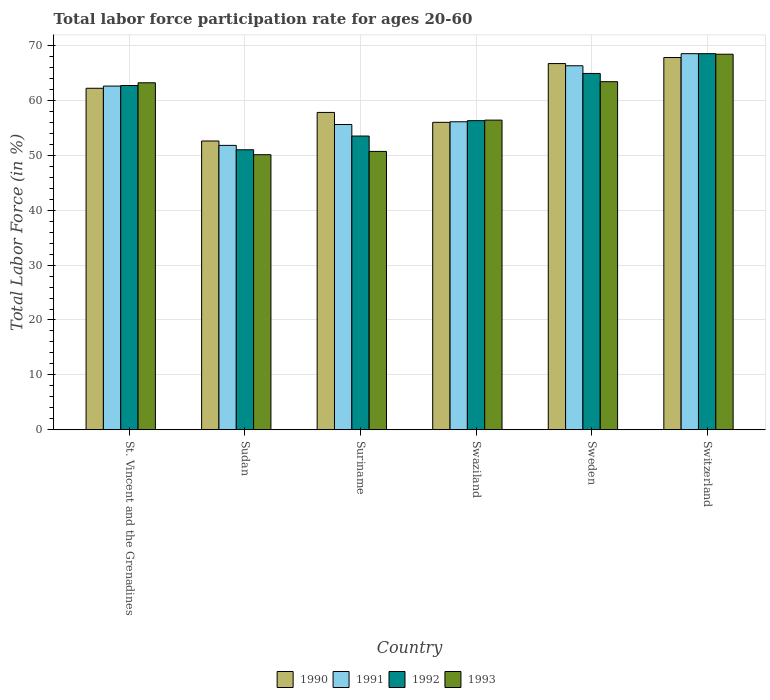How many groups of bars are there?
Offer a terse response. 6. Are the number of bars per tick equal to the number of legend labels?
Your answer should be very brief. Yes. What is the label of the 6th group of bars from the left?
Make the answer very short. Switzerland. What is the labor force participation rate in 1992 in Sudan?
Provide a short and direct response. 51. Across all countries, what is the maximum labor force participation rate in 1990?
Provide a succinct answer. 67.8. Across all countries, what is the minimum labor force participation rate in 1990?
Your response must be concise. 52.6. In which country was the labor force participation rate in 1992 maximum?
Your answer should be very brief. Switzerland. In which country was the labor force participation rate in 1993 minimum?
Ensure brevity in your answer.  Sudan. What is the total labor force participation rate in 1992 in the graph?
Your response must be concise. 356.9. What is the difference between the labor force participation rate in 1990 in Sweden and that in Switzerland?
Provide a succinct answer. -1.1. What is the difference between the labor force participation rate in 1993 in Sweden and the labor force participation rate in 1990 in Sudan?
Your answer should be compact. 10.8. What is the average labor force participation rate in 1993 per country?
Your answer should be very brief. 58.7. What is the difference between the labor force participation rate of/in 1990 and labor force participation rate of/in 1993 in Switzerland?
Make the answer very short. -0.6. In how many countries, is the labor force participation rate in 1992 greater than 46 %?
Your answer should be compact. 6. What is the ratio of the labor force participation rate in 1992 in Suriname to that in Switzerland?
Ensure brevity in your answer.  0.78. Is the labor force participation rate in 1993 in St. Vincent and the Grenadines less than that in Swaziland?
Your answer should be compact. No. What is the difference between the highest and the second highest labor force participation rate in 1993?
Make the answer very short. 5.2. What is the difference between the highest and the lowest labor force participation rate in 1992?
Provide a short and direct response. 17.5. In how many countries, is the labor force participation rate in 1993 greater than the average labor force participation rate in 1993 taken over all countries?
Ensure brevity in your answer.  3. Is the sum of the labor force participation rate in 1993 in St. Vincent and the Grenadines and Sudan greater than the maximum labor force participation rate in 1992 across all countries?
Provide a short and direct response. Yes. Is it the case that in every country, the sum of the labor force participation rate in 1991 and labor force participation rate in 1993 is greater than the sum of labor force participation rate in 1990 and labor force participation rate in 1992?
Keep it short and to the point. No. What does the 2nd bar from the left in St. Vincent and the Grenadines represents?
Offer a terse response. 1991. What does the 1st bar from the right in Switzerland represents?
Provide a short and direct response. 1993. How many bars are there?
Give a very brief answer. 24. Are all the bars in the graph horizontal?
Offer a very short reply. No. How many countries are there in the graph?
Offer a very short reply. 6. What is the difference between two consecutive major ticks on the Y-axis?
Your answer should be very brief. 10. Does the graph contain grids?
Your response must be concise. Yes. Where does the legend appear in the graph?
Offer a very short reply. Bottom center. How are the legend labels stacked?
Keep it short and to the point. Horizontal. What is the title of the graph?
Provide a short and direct response. Total labor force participation rate for ages 20-60. Does "1982" appear as one of the legend labels in the graph?
Ensure brevity in your answer.  No. What is the label or title of the X-axis?
Provide a succinct answer. Country. What is the label or title of the Y-axis?
Your answer should be compact. Total Labor Force (in %). What is the Total Labor Force (in %) of 1990 in St. Vincent and the Grenadines?
Your response must be concise. 62.2. What is the Total Labor Force (in %) in 1991 in St. Vincent and the Grenadines?
Offer a terse response. 62.6. What is the Total Labor Force (in %) of 1992 in St. Vincent and the Grenadines?
Give a very brief answer. 62.7. What is the Total Labor Force (in %) of 1993 in St. Vincent and the Grenadines?
Offer a terse response. 63.2. What is the Total Labor Force (in %) in 1990 in Sudan?
Offer a very short reply. 52.6. What is the Total Labor Force (in %) of 1991 in Sudan?
Ensure brevity in your answer.  51.8. What is the Total Labor Force (in %) of 1993 in Sudan?
Make the answer very short. 50.1. What is the Total Labor Force (in %) of 1990 in Suriname?
Give a very brief answer. 57.8. What is the Total Labor Force (in %) in 1991 in Suriname?
Your response must be concise. 55.6. What is the Total Labor Force (in %) in 1992 in Suriname?
Your answer should be very brief. 53.5. What is the Total Labor Force (in %) of 1993 in Suriname?
Provide a short and direct response. 50.7. What is the Total Labor Force (in %) in 1990 in Swaziland?
Give a very brief answer. 56. What is the Total Labor Force (in %) in 1991 in Swaziland?
Offer a very short reply. 56.1. What is the Total Labor Force (in %) of 1992 in Swaziland?
Give a very brief answer. 56.3. What is the Total Labor Force (in %) of 1993 in Swaziland?
Your response must be concise. 56.4. What is the Total Labor Force (in %) in 1990 in Sweden?
Your answer should be compact. 66.7. What is the Total Labor Force (in %) of 1991 in Sweden?
Ensure brevity in your answer.  66.3. What is the Total Labor Force (in %) of 1992 in Sweden?
Ensure brevity in your answer.  64.9. What is the Total Labor Force (in %) in 1993 in Sweden?
Your answer should be very brief. 63.4. What is the Total Labor Force (in %) of 1990 in Switzerland?
Make the answer very short. 67.8. What is the Total Labor Force (in %) in 1991 in Switzerland?
Provide a succinct answer. 68.5. What is the Total Labor Force (in %) of 1992 in Switzerland?
Your answer should be compact. 68.5. What is the Total Labor Force (in %) of 1993 in Switzerland?
Your answer should be compact. 68.4. Across all countries, what is the maximum Total Labor Force (in %) in 1990?
Make the answer very short. 67.8. Across all countries, what is the maximum Total Labor Force (in %) of 1991?
Keep it short and to the point. 68.5. Across all countries, what is the maximum Total Labor Force (in %) in 1992?
Offer a very short reply. 68.5. Across all countries, what is the maximum Total Labor Force (in %) of 1993?
Your answer should be compact. 68.4. Across all countries, what is the minimum Total Labor Force (in %) of 1990?
Ensure brevity in your answer.  52.6. Across all countries, what is the minimum Total Labor Force (in %) of 1991?
Ensure brevity in your answer.  51.8. Across all countries, what is the minimum Total Labor Force (in %) of 1992?
Offer a terse response. 51. Across all countries, what is the minimum Total Labor Force (in %) of 1993?
Your answer should be compact. 50.1. What is the total Total Labor Force (in %) of 1990 in the graph?
Offer a very short reply. 363.1. What is the total Total Labor Force (in %) in 1991 in the graph?
Offer a very short reply. 360.9. What is the total Total Labor Force (in %) in 1992 in the graph?
Make the answer very short. 356.9. What is the total Total Labor Force (in %) in 1993 in the graph?
Your response must be concise. 352.2. What is the difference between the Total Labor Force (in %) in 1992 in St. Vincent and the Grenadines and that in Sudan?
Give a very brief answer. 11.7. What is the difference between the Total Labor Force (in %) in 1990 in St. Vincent and the Grenadines and that in Suriname?
Give a very brief answer. 4.4. What is the difference between the Total Labor Force (in %) of 1991 in St. Vincent and the Grenadines and that in Suriname?
Your answer should be compact. 7. What is the difference between the Total Labor Force (in %) in 1993 in St. Vincent and the Grenadines and that in Suriname?
Make the answer very short. 12.5. What is the difference between the Total Labor Force (in %) in 1993 in St. Vincent and the Grenadines and that in Swaziland?
Your answer should be very brief. 6.8. What is the difference between the Total Labor Force (in %) in 1991 in St. Vincent and the Grenadines and that in Sweden?
Make the answer very short. -3.7. What is the difference between the Total Labor Force (in %) of 1992 in St. Vincent and the Grenadines and that in Sweden?
Provide a short and direct response. -2.2. What is the difference between the Total Labor Force (in %) in 1990 in St. Vincent and the Grenadines and that in Switzerland?
Offer a terse response. -5.6. What is the difference between the Total Labor Force (in %) in 1993 in St. Vincent and the Grenadines and that in Switzerland?
Provide a short and direct response. -5.2. What is the difference between the Total Labor Force (in %) in 1990 in Sudan and that in Suriname?
Offer a terse response. -5.2. What is the difference between the Total Labor Force (in %) of 1992 in Sudan and that in Suriname?
Provide a short and direct response. -2.5. What is the difference between the Total Labor Force (in %) of 1993 in Sudan and that in Suriname?
Ensure brevity in your answer.  -0.6. What is the difference between the Total Labor Force (in %) of 1990 in Sudan and that in Swaziland?
Give a very brief answer. -3.4. What is the difference between the Total Labor Force (in %) in 1992 in Sudan and that in Swaziland?
Offer a very short reply. -5.3. What is the difference between the Total Labor Force (in %) in 1993 in Sudan and that in Swaziland?
Offer a terse response. -6.3. What is the difference between the Total Labor Force (in %) of 1990 in Sudan and that in Sweden?
Ensure brevity in your answer.  -14.1. What is the difference between the Total Labor Force (in %) in 1992 in Sudan and that in Sweden?
Provide a short and direct response. -13.9. What is the difference between the Total Labor Force (in %) in 1993 in Sudan and that in Sweden?
Your answer should be compact. -13.3. What is the difference between the Total Labor Force (in %) of 1990 in Sudan and that in Switzerland?
Ensure brevity in your answer.  -15.2. What is the difference between the Total Labor Force (in %) in 1991 in Sudan and that in Switzerland?
Provide a short and direct response. -16.7. What is the difference between the Total Labor Force (in %) of 1992 in Sudan and that in Switzerland?
Provide a succinct answer. -17.5. What is the difference between the Total Labor Force (in %) in 1993 in Sudan and that in Switzerland?
Offer a very short reply. -18.3. What is the difference between the Total Labor Force (in %) in 1992 in Suriname and that in Swaziland?
Give a very brief answer. -2.8. What is the difference between the Total Labor Force (in %) in 1993 in Suriname and that in Swaziland?
Offer a terse response. -5.7. What is the difference between the Total Labor Force (in %) of 1991 in Suriname and that in Sweden?
Make the answer very short. -10.7. What is the difference between the Total Labor Force (in %) in 1993 in Suriname and that in Sweden?
Offer a terse response. -12.7. What is the difference between the Total Labor Force (in %) in 1990 in Suriname and that in Switzerland?
Your answer should be very brief. -10. What is the difference between the Total Labor Force (in %) of 1991 in Suriname and that in Switzerland?
Provide a succinct answer. -12.9. What is the difference between the Total Labor Force (in %) in 1993 in Suriname and that in Switzerland?
Your response must be concise. -17.7. What is the difference between the Total Labor Force (in %) of 1990 in Swaziland and that in Sweden?
Give a very brief answer. -10.7. What is the difference between the Total Labor Force (in %) in 1991 in Swaziland and that in Sweden?
Your answer should be compact. -10.2. What is the difference between the Total Labor Force (in %) of 1993 in Swaziland and that in Sweden?
Make the answer very short. -7. What is the difference between the Total Labor Force (in %) of 1991 in Swaziland and that in Switzerland?
Keep it short and to the point. -12.4. What is the difference between the Total Labor Force (in %) in 1990 in Sweden and that in Switzerland?
Offer a terse response. -1.1. What is the difference between the Total Labor Force (in %) in 1991 in Sweden and that in Switzerland?
Provide a short and direct response. -2.2. What is the difference between the Total Labor Force (in %) in 1993 in Sweden and that in Switzerland?
Keep it short and to the point. -5. What is the difference between the Total Labor Force (in %) in 1990 in St. Vincent and the Grenadines and the Total Labor Force (in %) in 1992 in Sudan?
Offer a very short reply. 11.2. What is the difference between the Total Labor Force (in %) of 1991 in St. Vincent and the Grenadines and the Total Labor Force (in %) of 1993 in Sudan?
Your answer should be very brief. 12.5. What is the difference between the Total Labor Force (in %) in 1990 in St. Vincent and the Grenadines and the Total Labor Force (in %) in 1993 in Suriname?
Provide a succinct answer. 11.5. What is the difference between the Total Labor Force (in %) of 1992 in St. Vincent and the Grenadines and the Total Labor Force (in %) of 1993 in Suriname?
Make the answer very short. 12. What is the difference between the Total Labor Force (in %) of 1990 in St. Vincent and the Grenadines and the Total Labor Force (in %) of 1991 in Swaziland?
Offer a very short reply. 6.1. What is the difference between the Total Labor Force (in %) in 1990 in St. Vincent and the Grenadines and the Total Labor Force (in %) in 1992 in Swaziland?
Offer a very short reply. 5.9. What is the difference between the Total Labor Force (in %) in 1990 in St. Vincent and the Grenadines and the Total Labor Force (in %) in 1993 in Swaziland?
Provide a succinct answer. 5.8. What is the difference between the Total Labor Force (in %) of 1992 in St. Vincent and the Grenadines and the Total Labor Force (in %) of 1993 in Swaziland?
Keep it short and to the point. 6.3. What is the difference between the Total Labor Force (in %) of 1990 in St. Vincent and the Grenadines and the Total Labor Force (in %) of 1993 in Sweden?
Your answer should be very brief. -1.2. What is the difference between the Total Labor Force (in %) of 1991 in St. Vincent and the Grenadines and the Total Labor Force (in %) of 1992 in Sweden?
Keep it short and to the point. -2.3. What is the difference between the Total Labor Force (in %) in 1990 in St. Vincent and the Grenadines and the Total Labor Force (in %) in 1993 in Switzerland?
Your response must be concise. -6.2. What is the difference between the Total Labor Force (in %) in 1991 in St. Vincent and the Grenadines and the Total Labor Force (in %) in 1993 in Switzerland?
Provide a short and direct response. -5.8. What is the difference between the Total Labor Force (in %) of 1990 in Sudan and the Total Labor Force (in %) of 1992 in Suriname?
Ensure brevity in your answer.  -0.9. What is the difference between the Total Labor Force (in %) of 1991 in Sudan and the Total Labor Force (in %) of 1993 in Suriname?
Your answer should be very brief. 1.1. What is the difference between the Total Labor Force (in %) of 1990 in Sudan and the Total Labor Force (in %) of 1991 in Swaziland?
Provide a succinct answer. -3.5. What is the difference between the Total Labor Force (in %) of 1990 in Sudan and the Total Labor Force (in %) of 1992 in Swaziland?
Your response must be concise. -3.7. What is the difference between the Total Labor Force (in %) in 1990 in Sudan and the Total Labor Force (in %) in 1993 in Swaziland?
Offer a very short reply. -3.8. What is the difference between the Total Labor Force (in %) of 1991 in Sudan and the Total Labor Force (in %) of 1993 in Swaziland?
Provide a succinct answer. -4.6. What is the difference between the Total Labor Force (in %) in 1990 in Sudan and the Total Labor Force (in %) in 1991 in Sweden?
Make the answer very short. -13.7. What is the difference between the Total Labor Force (in %) in 1990 in Sudan and the Total Labor Force (in %) in 1992 in Sweden?
Your answer should be very brief. -12.3. What is the difference between the Total Labor Force (in %) of 1990 in Sudan and the Total Labor Force (in %) of 1993 in Sweden?
Provide a short and direct response. -10.8. What is the difference between the Total Labor Force (in %) of 1991 in Sudan and the Total Labor Force (in %) of 1992 in Sweden?
Ensure brevity in your answer.  -13.1. What is the difference between the Total Labor Force (in %) in 1991 in Sudan and the Total Labor Force (in %) in 1993 in Sweden?
Ensure brevity in your answer.  -11.6. What is the difference between the Total Labor Force (in %) of 1990 in Sudan and the Total Labor Force (in %) of 1991 in Switzerland?
Provide a succinct answer. -15.9. What is the difference between the Total Labor Force (in %) of 1990 in Sudan and the Total Labor Force (in %) of 1992 in Switzerland?
Your answer should be compact. -15.9. What is the difference between the Total Labor Force (in %) in 1990 in Sudan and the Total Labor Force (in %) in 1993 in Switzerland?
Make the answer very short. -15.8. What is the difference between the Total Labor Force (in %) of 1991 in Sudan and the Total Labor Force (in %) of 1992 in Switzerland?
Your answer should be very brief. -16.7. What is the difference between the Total Labor Force (in %) of 1991 in Sudan and the Total Labor Force (in %) of 1993 in Switzerland?
Offer a terse response. -16.6. What is the difference between the Total Labor Force (in %) in 1992 in Sudan and the Total Labor Force (in %) in 1993 in Switzerland?
Your answer should be compact. -17.4. What is the difference between the Total Labor Force (in %) in 1990 in Suriname and the Total Labor Force (in %) in 1993 in Swaziland?
Provide a short and direct response. 1.4. What is the difference between the Total Labor Force (in %) in 1990 in Suriname and the Total Labor Force (in %) in 1992 in Sweden?
Make the answer very short. -7.1. What is the difference between the Total Labor Force (in %) of 1990 in Suriname and the Total Labor Force (in %) of 1993 in Sweden?
Provide a short and direct response. -5.6. What is the difference between the Total Labor Force (in %) of 1991 in Suriname and the Total Labor Force (in %) of 1993 in Sweden?
Provide a succinct answer. -7.8. What is the difference between the Total Labor Force (in %) in 1990 in Suriname and the Total Labor Force (in %) in 1993 in Switzerland?
Make the answer very short. -10.6. What is the difference between the Total Labor Force (in %) of 1992 in Suriname and the Total Labor Force (in %) of 1993 in Switzerland?
Ensure brevity in your answer.  -14.9. What is the difference between the Total Labor Force (in %) of 1990 in Swaziland and the Total Labor Force (in %) of 1991 in Sweden?
Keep it short and to the point. -10.3. What is the difference between the Total Labor Force (in %) in 1990 in Swaziland and the Total Labor Force (in %) in 1992 in Sweden?
Your answer should be compact. -8.9. What is the difference between the Total Labor Force (in %) in 1990 in Swaziland and the Total Labor Force (in %) in 1993 in Sweden?
Your answer should be compact. -7.4. What is the difference between the Total Labor Force (in %) of 1991 in Swaziland and the Total Labor Force (in %) of 1993 in Sweden?
Ensure brevity in your answer.  -7.3. What is the difference between the Total Labor Force (in %) of 1990 in Swaziland and the Total Labor Force (in %) of 1991 in Switzerland?
Provide a short and direct response. -12.5. What is the difference between the Total Labor Force (in %) of 1990 in Swaziland and the Total Labor Force (in %) of 1992 in Switzerland?
Make the answer very short. -12.5. What is the difference between the Total Labor Force (in %) in 1990 in Swaziland and the Total Labor Force (in %) in 1993 in Switzerland?
Your response must be concise. -12.4. What is the difference between the Total Labor Force (in %) in 1991 in Swaziland and the Total Labor Force (in %) in 1992 in Switzerland?
Offer a terse response. -12.4. What is the difference between the Total Labor Force (in %) in 1992 in Swaziland and the Total Labor Force (in %) in 1993 in Switzerland?
Provide a succinct answer. -12.1. What is the difference between the Total Labor Force (in %) of 1991 in Sweden and the Total Labor Force (in %) of 1992 in Switzerland?
Give a very brief answer. -2.2. What is the difference between the Total Labor Force (in %) of 1991 in Sweden and the Total Labor Force (in %) of 1993 in Switzerland?
Make the answer very short. -2.1. What is the difference between the Total Labor Force (in %) of 1992 in Sweden and the Total Labor Force (in %) of 1993 in Switzerland?
Your answer should be compact. -3.5. What is the average Total Labor Force (in %) in 1990 per country?
Ensure brevity in your answer.  60.52. What is the average Total Labor Force (in %) in 1991 per country?
Your answer should be very brief. 60.15. What is the average Total Labor Force (in %) of 1992 per country?
Provide a succinct answer. 59.48. What is the average Total Labor Force (in %) of 1993 per country?
Keep it short and to the point. 58.7. What is the difference between the Total Labor Force (in %) in 1990 and Total Labor Force (in %) in 1991 in St. Vincent and the Grenadines?
Your answer should be very brief. -0.4. What is the difference between the Total Labor Force (in %) in 1990 and Total Labor Force (in %) in 1993 in St. Vincent and the Grenadines?
Offer a very short reply. -1. What is the difference between the Total Labor Force (in %) in 1991 and Total Labor Force (in %) in 1992 in St. Vincent and the Grenadines?
Ensure brevity in your answer.  -0.1. What is the difference between the Total Labor Force (in %) in 1990 and Total Labor Force (in %) in 1991 in Sudan?
Offer a very short reply. 0.8. What is the difference between the Total Labor Force (in %) of 1990 and Total Labor Force (in %) of 1992 in Sudan?
Your answer should be compact. 1.6. What is the difference between the Total Labor Force (in %) of 1990 and Total Labor Force (in %) of 1993 in Sudan?
Your response must be concise. 2.5. What is the difference between the Total Labor Force (in %) in 1991 and Total Labor Force (in %) in 1992 in Sudan?
Ensure brevity in your answer.  0.8. What is the difference between the Total Labor Force (in %) in 1991 and Total Labor Force (in %) in 1993 in Sudan?
Offer a very short reply. 1.7. What is the difference between the Total Labor Force (in %) of 1991 and Total Labor Force (in %) of 1992 in Suriname?
Ensure brevity in your answer.  2.1. What is the difference between the Total Labor Force (in %) in 1991 and Total Labor Force (in %) in 1993 in Suriname?
Ensure brevity in your answer.  4.9. What is the difference between the Total Labor Force (in %) of 1992 and Total Labor Force (in %) of 1993 in Suriname?
Offer a very short reply. 2.8. What is the difference between the Total Labor Force (in %) in 1990 and Total Labor Force (in %) in 1993 in Swaziland?
Make the answer very short. -0.4. What is the difference between the Total Labor Force (in %) in 1991 and Total Labor Force (in %) in 1992 in Swaziland?
Your answer should be very brief. -0.2. What is the difference between the Total Labor Force (in %) of 1991 and Total Labor Force (in %) of 1993 in Swaziland?
Provide a succinct answer. -0.3. What is the difference between the Total Labor Force (in %) in 1990 and Total Labor Force (in %) in 1991 in Sweden?
Your response must be concise. 0.4. What is the difference between the Total Labor Force (in %) in 1990 and Total Labor Force (in %) in 1993 in Sweden?
Ensure brevity in your answer.  3.3. What is the difference between the Total Labor Force (in %) of 1990 and Total Labor Force (in %) of 1991 in Switzerland?
Ensure brevity in your answer.  -0.7. What is the difference between the Total Labor Force (in %) in 1990 and Total Labor Force (in %) in 1992 in Switzerland?
Your response must be concise. -0.7. What is the difference between the Total Labor Force (in %) in 1990 and Total Labor Force (in %) in 1993 in Switzerland?
Offer a very short reply. -0.6. What is the difference between the Total Labor Force (in %) of 1991 and Total Labor Force (in %) of 1992 in Switzerland?
Your answer should be compact. 0. What is the difference between the Total Labor Force (in %) of 1992 and Total Labor Force (in %) of 1993 in Switzerland?
Offer a very short reply. 0.1. What is the ratio of the Total Labor Force (in %) in 1990 in St. Vincent and the Grenadines to that in Sudan?
Provide a short and direct response. 1.18. What is the ratio of the Total Labor Force (in %) of 1991 in St. Vincent and the Grenadines to that in Sudan?
Give a very brief answer. 1.21. What is the ratio of the Total Labor Force (in %) in 1992 in St. Vincent and the Grenadines to that in Sudan?
Your answer should be very brief. 1.23. What is the ratio of the Total Labor Force (in %) of 1993 in St. Vincent and the Grenadines to that in Sudan?
Offer a terse response. 1.26. What is the ratio of the Total Labor Force (in %) of 1990 in St. Vincent and the Grenadines to that in Suriname?
Your answer should be compact. 1.08. What is the ratio of the Total Labor Force (in %) of 1991 in St. Vincent and the Grenadines to that in Suriname?
Give a very brief answer. 1.13. What is the ratio of the Total Labor Force (in %) of 1992 in St. Vincent and the Grenadines to that in Suriname?
Your response must be concise. 1.17. What is the ratio of the Total Labor Force (in %) in 1993 in St. Vincent and the Grenadines to that in Suriname?
Make the answer very short. 1.25. What is the ratio of the Total Labor Force (in %) in 1990 in St. Vincent and the Grenadines to that in Swaziland?
Offer a very short reply. 1.11. What is the ratio of the Total Labor Force (in %) of 1991 in St. Vincent and the Grenadines to that in Swaziland?
Offer a very short reply. 1.12. What is the ratio of the Total Labor Force (in %) in 1992 in St. Vincent and the Grenadines to that in Swaziland?
Your answer should be very brief. 1.11. What is the ratio of the Total Labor Force (in %) in 1993 in St. Vincent and the Grenadines to that in Swaziland?
Offer a very short reply. 1.12. What is the ratio of the Total Labor Force (in %) of 1990 in St. Vincent and the Grenadines to that in Sweden?
Offer a terse response. 0.93. What is the ratio of the Total Labor Force (in %) of 1991 in St. Vincent and the Grenadines to that in Sweden?
Make the answer very short. 0.94. What is the ratio of the Total Labor Force (in %) of 1992 in St. Vincent and the Grenadines to that in Sweden?
Offer a very short reply. 0.97. What is the ratio of the Total Labor Force (in %) of 1993 in St. Vincent and the Grenadines to that in Sweden?
Keep it short and to the point. 1. What is the ratio of the Total Labor Force (in %) in 1990 in St. Vincent and the Grenadines to that in Switzerland?
Your answer should be very brief. 0.92. What is the ratio of the Total Labor Force (in %) in 1991 in St. Vincent and the Grenadines to that in Switzerland?
Keep it short and to the point. 0.91. What is the ratio of the Total Labor Force (in %) in 1992 in St. Vincent and the Grenadines to that in Switzerland?
Offer a terse response. 0.92. What is the ratio of the Total Labor Force (in %) in 1993 in St. Vincent and the Grenadines to that in Switzerland?
Offer a terse response. 0.92. What is the ratio of the Total Labor Force (in %) in 1990 in Sudan to that in Suriname?
Keep it short and to the point. 0.91. What is the ratio of the Total Labor Force (in %) of 1991 in Sudan to that in Suriname?
Offer a terse response. 0.93. What is the ratio of the Total Labor Force (in %) of 1992 in Sudan to that in Suriname?
Your answer should be very brief. 0.95. What is the ratio of the Total Labor Force (in %) in 1990 in Sudan to that in Swaziland?
Offer a terse response. 0.94. What is the ratio of the Total Labor Force (in %) in 1991 in Sudan to that in Swaziland?
Ensure brevity in your answer.  0.92. What is the ratio of the Total Labor Force (in %) in 1992 in Sudan to that in Swaziland?
Ensure brevity in your answer.  0.91. What is the ratio of the Total Labor Force (in %) of 1993 in Sudan to that in Swaziland?
Provide a short and direct response. 0.89. What is the ratio of the Total Labor Force (in %) in 1990 in Sudan to that in Sweden?
Keep it short and to the point. 0.79. What is the ratio of the Total Labor Force (in %) in 1991 in Sudan to that in Sweden?
Your response must be concise. 0.78. What is the ratio of the Total Labor Force (in %) of 1992 in Sudan to that in Sweden?
Your answer should be very brief. 0.79. What is the ratio of the Total Labor Force (in %) of 1993 in Sudan to that in Sweden?
Offer a very short reply. 0.79. What is the ratio of the Total Labor Force (in %) of 1990 in Sudan to that in Switzerland?
Ensure brevity in your answer.  0.78. What is the ratio of the Total Labor Force (in %) of 1991 in Sudan to that in Switzerland?
Your response must be concise. 0.76. What is the ratio of the Total Labor Force (in %) of 1992 in Sudan to that in Switzerland?
Give a very brief answer. 0.74. What is the ratio of the Total Labor Force (in %) of 1993 in Sudan to that in Switzerland?
Ensure brevity in your answer.  0.73. What is the ratio of the Total Labor Force (in %) of 1990 in Suriname to that in Swaziland?
Give a very brief answer. 1.03. What is the ratio of the Total Labor Force (in %) of 1992 in Suriname to that in Swaziland?
Provide a succinct answer. 0.95. What is the ratio of the Total Labor Force (in %) in 1993 in Suriname to that in Swaziland?
Your answer should be compact. 0.9. What is the ratio of the Total Labor Force (in %) in 1990 in Suriname to that in Sweden?
Offer a very short reply. 0.87. What is the ratio of the Total Labor Force (in %) of 1991 in Suriname to that in Sweden?
Your response must be concise. 0.84. What is the ratio of the Total Labor Force (in %) of 1992 in Suriname to that in Sweden?
Offer a very short reply. 0.82. What is the ratio of the Total Labor Force (in %) of 1993 in Suriname to that in Sweden?
Offer a terse response. 0.8. What is the ratio of the Total Labor Force (in %) of 1990 in Suriname to that in Switzerland?
Keep it short and to the point. 0.85. What is the ratio of the Total Labor Force (in %) in 1991 in Suriname to that in Switzerland?
Offer a terse response. 0.81. What is the ratio of the Total Labor Force (in %) of 1992 in Suriname to that in Switzerland?
Keep it short and to the point. 0.78. What is the ratio of the Total Labor Force (in %) of 1993 in Suriname to that in Switzerland?
Your answer should be compact. 0.74. What is the ratio of the Total Labor Force (in %) of 1990 in Swaziland to that in Sweden?
Your answer should be compact. 0.84. What is the ratio of the Total Labor Force (in %) in 1991 in Swaziland to that in Sweden?
Your answer should be compact. 0.85. What is the ratio of the Total Labor Force (in %) in 1992 in Swaziland to that in Sweden?
Your answer should be very brief. 0.87. What is the ratio of the Total Labor Force (in %) in 1993 in Swaziland to that in Sweden?
Make the answer very short. 0.89. What is the ratio of the Total Labor Force (in %) of 1990 in Swaziland to that in Switzerland?
Provide a short and direct response. 0.83. What is the ratio of the Total Labor Force (in %) in 1991 in Swaziland to that in Switzerland?
Your answer should be compact. 0.82. What is the ratio of the Total Labor Force (in %) in 1992 in Swaziland to that in Switzerland?
Your answer should be very brief. 0.82. What is the ratio of the Total Labor Force (in %) in 1993 in Swaziland to that in Switzerland?
Provide a short and direct response. 0.82. What is the ratio of the Total Labor Force (in %) in 1990 in Sweden to that in Switzerland?
Provide a succinct answer. 0.98. What is the ratio of the Total Labor Force (in %) of 1991 in Sweden to that in Switzerland?
Offer a very short reply. 0.97. What is the ratio of the Total Labor Force (in %) in 1992 in Sweden to that in Switzerland?
Provide a succinct answer. 0.95. What is the ratio of the Total Labor Force (in %) in 1993 in Sweden to that in Switzerland?
Keep it short and to the point. 0.93. What is the difference between the highest and the second highest Total Labor Force (in %) in 1990?
Keep it short and to the point. 1.1. What is the difference between the highest and the second highest Total Labor Force (in %) of 1991?
Provide a short and direct response. 2.2. What is the difference between the highest and the second highest Total Labor Force (in %) in 1993?
Offer a very short reply. 5. What is the difference between the highest and the lowest Total Labor Force (in %) of 1990?
Keep it short and to the point. 15.2. 